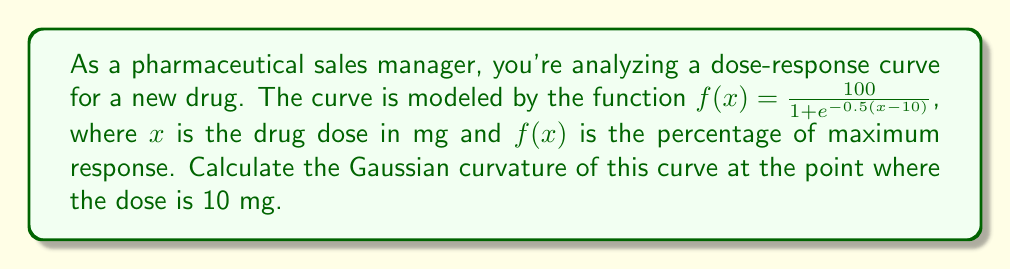Give your solution to this math problem. To analyze the curvature of the dose-response curve using differential geometry, we need to follow these steps:

1) First, we need to parameterize the curve. We can do this by considering it as a surface in 3D space:

   $r(x) = (x, f(x), 0)$

2) The Gaussian curvature K for a curve in 2D space embedded in 3D is given by:

   $K = \frac{f''(x)}{(1 + [f'(x)]^2)^{3/2}}$

3) We need to find $f'(x)$ and $f''(x)$:

   $f'(x) = \frac{100 \cdot 0.5e^{-0.5(x-10)}}{(1 + e^{-0.5(x-10)})^2} = \frac{50e^{-0.5(x-10)}}{(1 + e^{-0.5(x-10)})^2}$

   $f''(x) = \frac{50e^{-0.5(x-10)}(-0.5)(1 + e^{-0.5(x-10)})^2 - 50e^{-0.5(x-10)} \cdot 2(1 + e^{-0.5(x-10)})(-0.5e^{-0.5(x-10)})}{(1 + e^{-0.5(x-10)})^4}$

4) At x = 10:

   $f'(10) = \frac{50e^0}{(1 + e^0)^2} = \frac{50}{4} = 12.5$

   $f''(10) = \frac{50(-0.5)(1 + 1)^2 - 50 \cdot 2(1 + 1)(-0.5)}{(1 + 1)^4} = \frac{-50 + 100}{16} = \frac{50}{16} = 3.125$

5) Now we can calculate the Gaussian curvature:

   $K = \frac{f''(10)}{(1 + [f'(10)]^2)^{3/2}} = \frac{3.125}{(1 + 12.5^2)^{3/2}}$

6) Simplify:

   $K = \frac{3.125}{(157.25)^{3/2}} \approx 0.001589$
Answer: The Gaussian curvature of the dose-response curve at x = 10 mg is approximately 0.001589. 